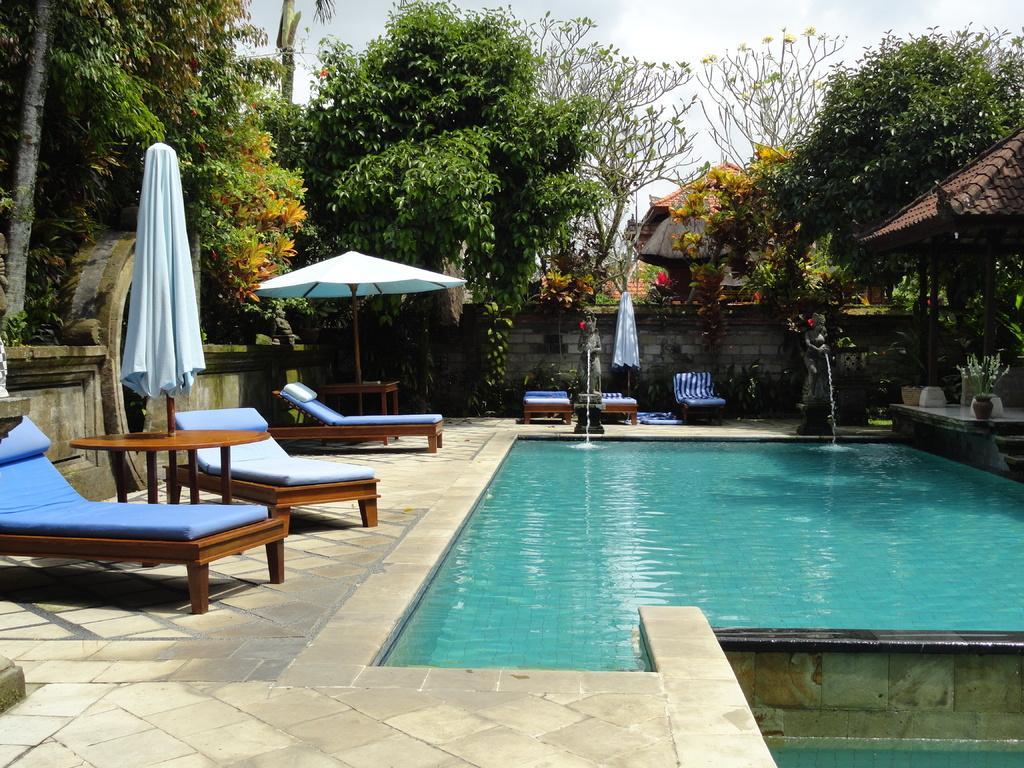Could you give a brief overview of what you see in this image? In this image I can see swimming pole and there are some beds and tents, trees visible on the left side and there is a tent house, wall ,sculpture , beds, house, plants and trees in the middle and the sky at the top. 